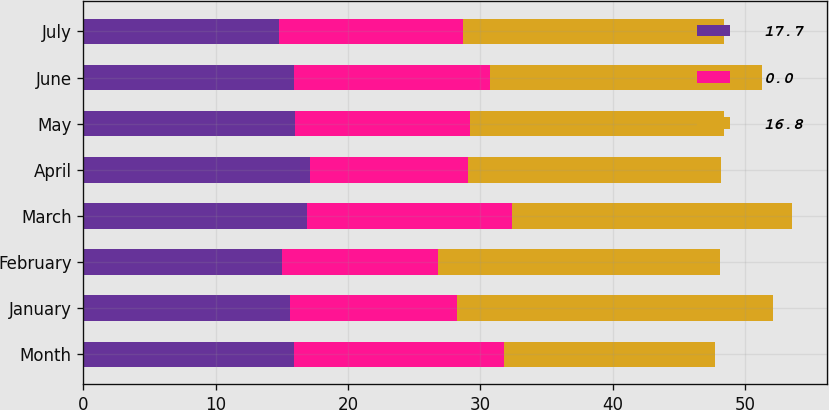<chart> <loc_0><loc_0><loc_500><loc_500><stacked_bar_chart><ecel><fcel>Month<fcel>January<fcel>February<fcel>March<fcel>April<fcel>May<fcel>June<fcel>July<nl><fcel>17.7<fcel>15.9<fcel>15.6<fcel>15<fcel>16.9<fcel>17.1<fcel>16<fcel>15.9<fcel>14.8<nl><fcel>0<fcel>15.9<fcel>12.6<fcel>11.8<fcel>15.5<fcel>12<fcel>13.2<fcel>14.8<fcel>13.9<nl><fcel>16.8<fcel>15.9<fcel>23.9<fcel>21.3<fcel>21.1<fcel>19.1<fcel>19.2<fcel>20.6<fcel>19.7<nl></chart> 